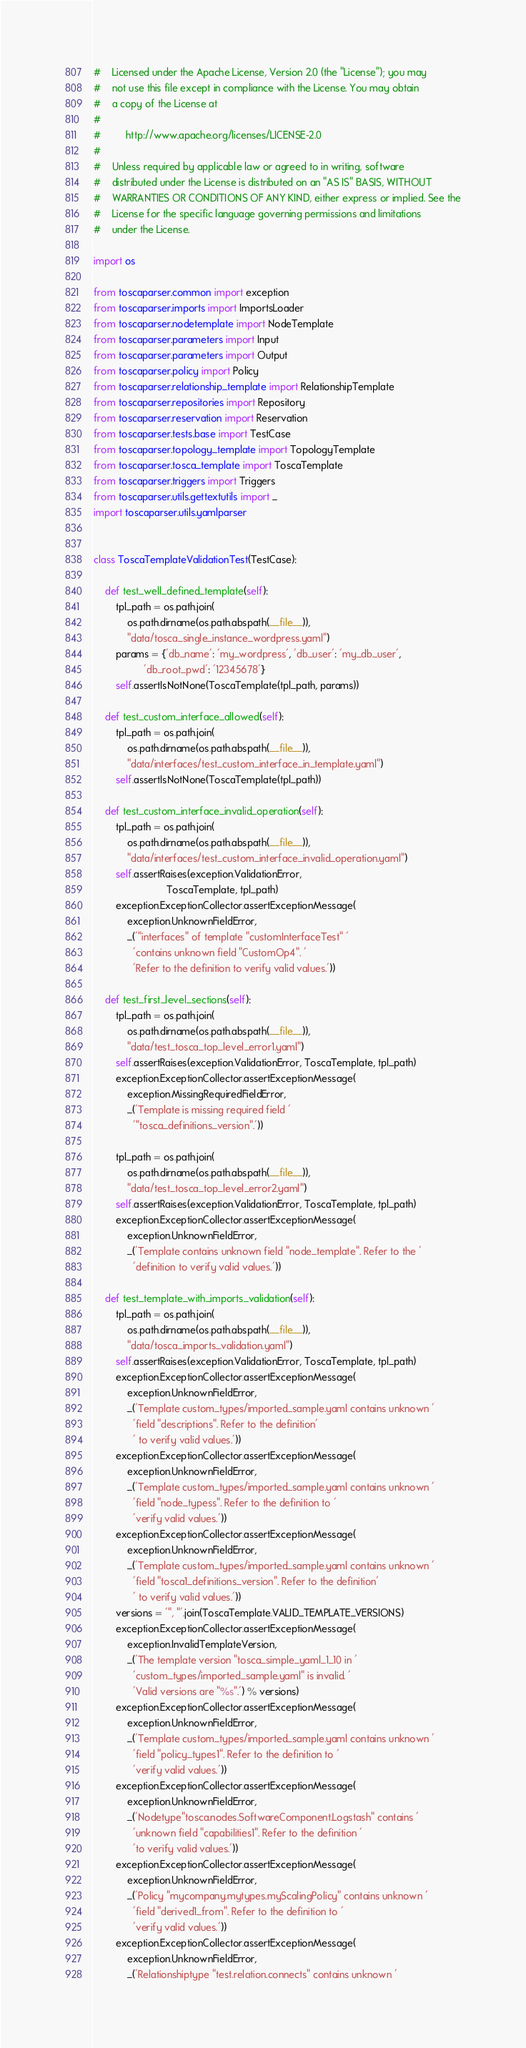<code> <loc_0><loc_0><loc_500><loc_500><_Python_>#    Licensed under the Apache License, Version 2.0 (the "License"); you may
#    not use this file except in compliance with the License. You may obtain
#    a copy of the License at
#
#         http://www.apache.org/licenses/LICENSE-2.0
#
#    Unless required by applicable law or agreed to in writing, software
#    distributed under the License is distributed on an "AS IS" BASIS, WITHOUT
#    WARRANTIES OR CONDITIONS OF ANY KIND, either express or implied. See the
#    License for the specific language governing permissions and limitations
#    under the License.

import os

from toscaparser.common import exception
from toscaparser.imports import ImportsLoader
from toscaparser.nodetemplate import NodeTemplate
from toscaparser.parameters import Input
from toscaparser.parameters import Output
from toscaparser.policy import Policy
from toscaparser.relationship_template import RelationshipTemplate
from toscaparser.repositories import Repository
from toscaparser.reservation import Reservation
from toscaparser.tests.base import TestCase
from toscaparser.topology_template import TopologyTemplate
from toscaparser.tosca_template import ToscaTemplate
from toscaparser.triggers import Triggers
from toscaparser.utils.gettextutils import _
import toscaparser.utils.yamlparser


class ToscaTemplateValidationTest(TestCase):

    def test_well_defined_template(self):
        tpl_path = os.path.join(
            os.path.dirname(os.path.abspath(__file__)),
            "data/tosca_single_instance_wordpress.yaml")
        params = {'db_name': 'my_wordpress', 'db_user': 'my_db_user',
                  'db_root_pwd': '12345678'}
        self.assertIsNotNone(ToscaTemplate(tpl_path, params))

    def test_custom_interface_allowed(self):
        tpl_path = os.path.join(
            os.path.dirname(os.path.abspath(__file__)),
            "data/interfaces/test_custom_interface_in_template.yaml")
        self.assertIsNotNone(ToscaTemplate(tpl_path))

    def test_custom_interface_invalid_operation(self):
        tpl_path = os.path.join(
            os.path.dirname(os.path.abspath(__file__)),
            "data/interfaces/test_custom_interface_invalid_operation.yaml")
        self.assertRaises(exception.ValidationError,
                          ToscaTemplate, tpl_path)
        exception.ExceptionCollector.assertExceptionMessage(
            exception.UnknownFieldError,
            _('"interfaces" of template "customInterfaceTest" '
              'contains unknown field "CustomOp4". '
              'Refer to the definition to verify valid values.'))

    def test_first_level_sections(self):
        tpl_path = os.path.join(
            os.path.dirname(os.path.abspath(__file__)),
            "data/test_tosca_top_level_error1.yaml")
        self.assertRaises(exception.ValidationError, ToscaTemplate, tpl_path)
        exception.ExceptionCollector.assertExceptionMessage(
            exception.MissingRequiredFieldError,
            _('Template is missing required field '
              '"tosca_definitions_version".'))

        tpl_path = os.path.join(
            os.path.dirname(os.path.abspath(__file__)),
            "data/test_tosca_top_level_error2.yaml")
        self.assertRaises(exception.ValidationError, ToscaTemplate, tpl_path)
        exception.ExceptionCollector.assertExceptionMessage(
            exception.UnknownFieldError,
            _('Template contains unknown field "node_template". Refer to the '
              'definition to verify valid values.'))

    def test_template_with_imports_validation(self):
        tpl_path = os.path.join(
            os.path.dirname(os.path.abspath(__file__)),
            "data/tosca_imports_validation.yaml")
        self.assertRaises(exception.ValidationError, ToscaTemplate, tpl_path)
        exception.ExceptionCollector.assertExceptionMessage(
            exception.UnknownFieldError,
            _('Template custom_types/imported_sample.yaml contains unknown '
              'field "descriptions". Refer to the definition'
              ' to verify valid values.'))
        exception.ExceptionCollector.assertExceptionMessage(
            exception.UnknownFieldError,
            _('Template custom_types/imported_sample.yaml contains unknown '
              'field "node_typess". Refer to the definition to '
              'verify valid values.'))
        exception.ExceptionCollector.assertExceptionMessage(
            exception.UnknownFieldError,
            _('Template custom_types/imported_sample.yaml contains unknown '
              'field "tosca1_definitions_version". Refer to the definition'
              ' to verify valid values.'))
        versions = '", "'.join(ToscaTemplate.VALID_TEMPLATE_VERSIONS)
        exception.ExceptionCollector.assertExceptionMessage(
            exception.InvalidTemplateVersion,
            _('The template version "tosca_simple_yaml_1_10 in '
              'custom_types/imported_sample.yaml" is invalid. '
              'Valid versions are "%s".') % versions)
        exception.ExceptionCollector.assertExceptionMessage(
            exception.UnknownFieldError,
            _('Template custom_types/imported_sample.yaml contains unknown '
              'field "policy_types1". Refer to the definition to '
              'verify valid values.'))
        exception.ExceptionCollector.assertExceptionMessage(
            exception.UnknownFieldError,
            _('Nodetype"tosca.nodes.SoftwareComponent.Logstash" contains '
              'unknown field "capabilities1". Refer to the definition '
              'to verify valid values.'))
        exception.ExceptionCollector.assertExceptionMessage(
            exception.UnknownFieldError,
            _('Policy "mycompany.mytypes.myScalingPolicy" contains unknown '
              'field "derived1_from". Refer to the definition to '
              'verify valid values.'))
        exception.ExceptionCollector.assertExceptionMessage(
            exception.UnknownFieldError,
            _('Relationshiptype "test.relation.connects" contains unknown '</code> 